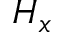Convert formula to latex. <formula><loc_0><loc_0><loc_500><loc_500>H _ { x }</formula> 